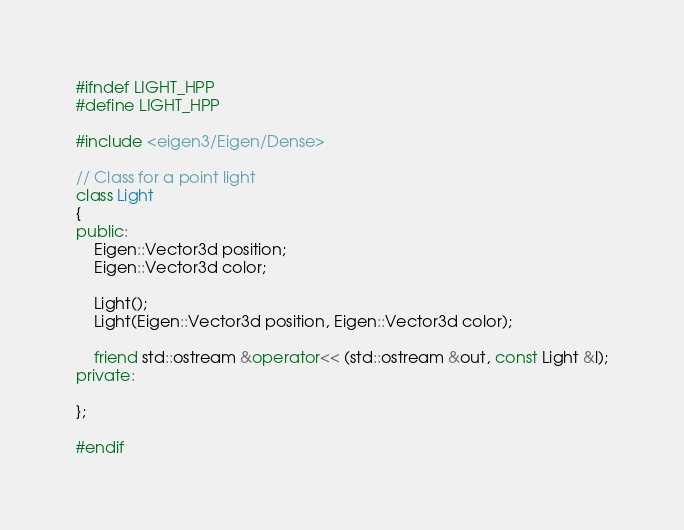<code> <loc_0><loc_0><loc_500><loc_500><_C++_>#ifndef LIGHT_HPP
#define LIGHT_HPP

#include <eigen3/Eigen/Dense>

// Class for a point light
class Light
{
public:
	Eigen::Vector3d position;
	Eigen::Vector3d color;

	Light();
	Light(Eigen::Vector3d position, Eigen::Vector3d color);

	friend std::ostream &operator<< (std::ostream &out, const Light &l);
private:

};

#endif</code> 